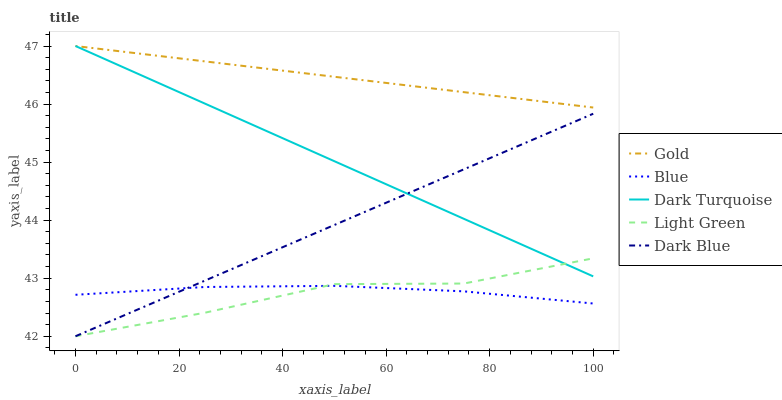Does Dark Turquoise have the minimum area under the curve?
Answer yes or no. No. Does Dark Turquoise have the maximum area under the curve?
Answer yes or no. No. Is Dark Turquoise the smoothest?
Answer yes or no. No. Is Dark Turquoise the roughest?
Answer yes or no. No. Does Dark Turquoise have the lowest value?
Answer yes or no. No. Does Light Green have the highest value?
Answer yes or no. No. Is Blue less than Dark Turquoise?
Answer yes or no. Yes. Is Gold greater than Blue?
Answer yes or no. Yes. Does Blue intersect Dark Turquoise?
Answer yes or no. No. 